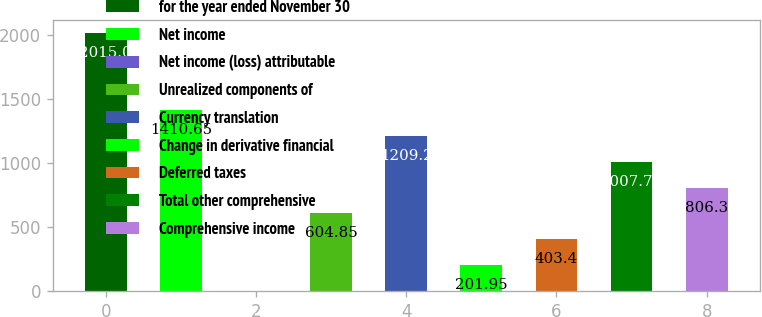Convert chart to OTSL. <chart><loc_0><loc_0><loc_500><loc_500><bar_chart><fcel>for the year ended November 30<fcel>Net income<fcel>Net income (loss) attributable<fcel>Unrealized components of<fcel>Currency translation<fcel>Change in derivative financial<fcel>Deferred taxes<fcel>Total other comprehensive<fcel>Comprehensive income<nl><fcel>2015<fcel>1410.65<fcel>0.5<fcel>604.85<fcel>1209.2<fcel>201.95<fcel>403.4<fcel>1007.75<fcel>806.3<nl></chart> 